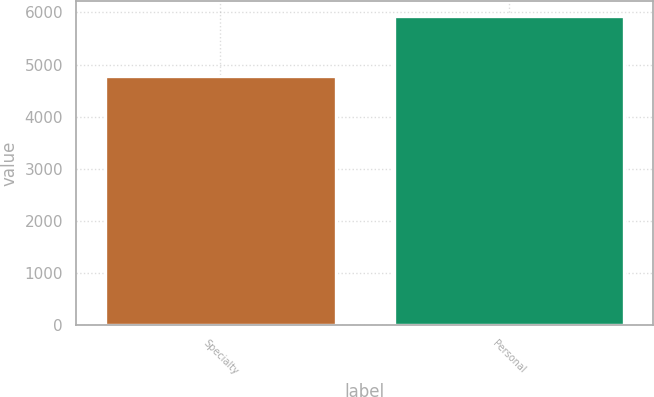Convert chart to OTSL. <chart><loc_0><loc_0><loc_500><loc_500><bar_chart><fcel>Specialty<fcel>Personal<nl><fcel>4771<fcel>5929<nl></chart> 